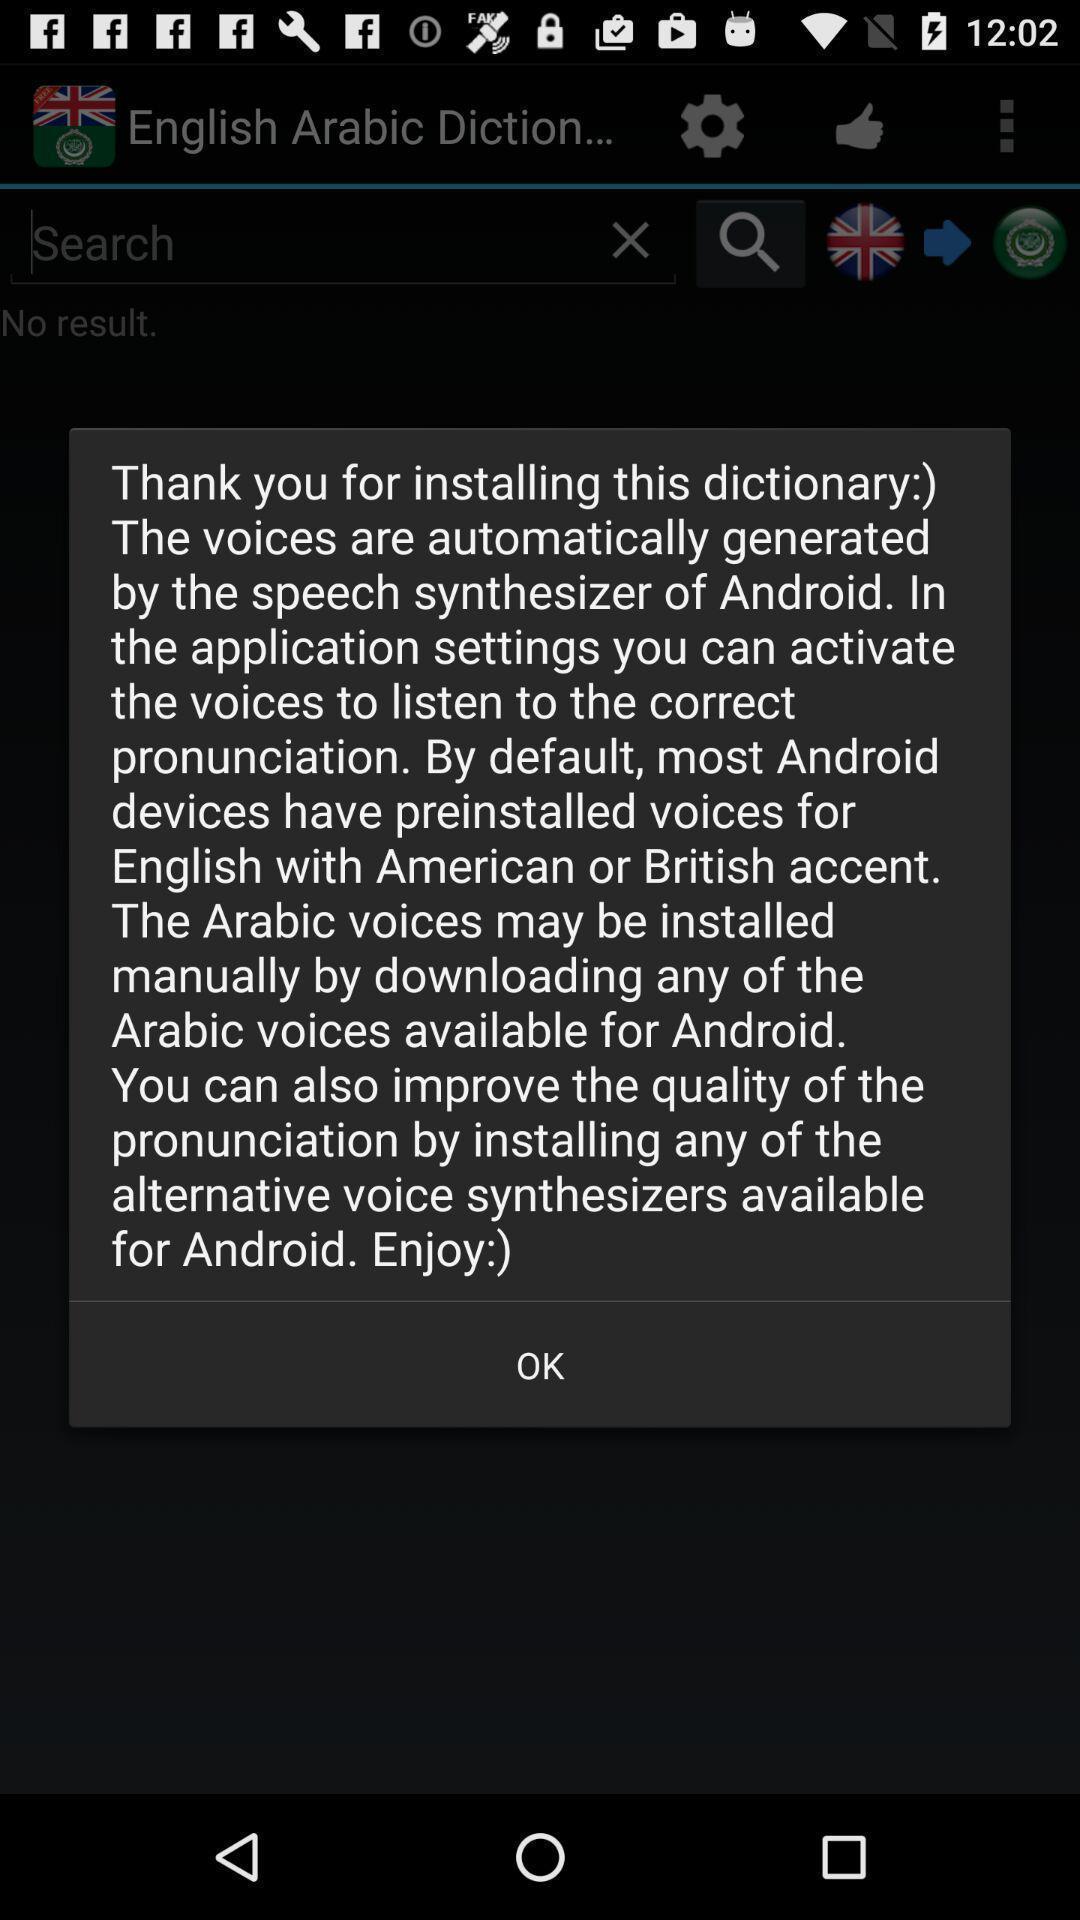Describe the visual elements of this screenshot. Pop-up shows thank you message. 